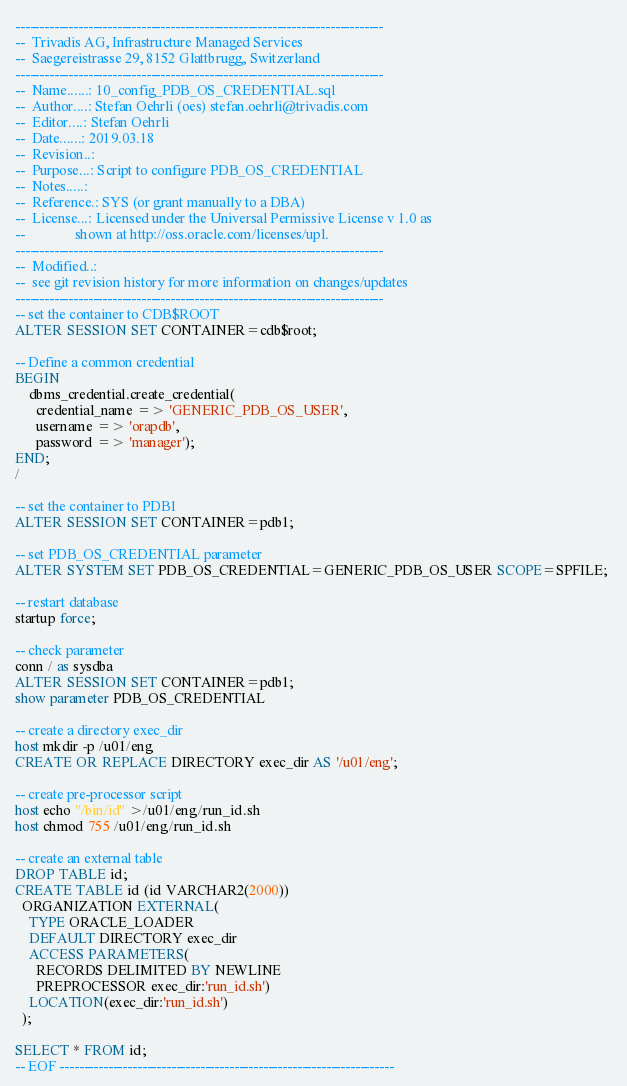<code> <loc_0><loc_0><loc_500><loc_500><_SQL_>----------------------------------------------------------------------------
--  Trivadis AG, Infrastructure Managed Services
--  Saegereistrasse 29, 8152 Glattbrugg, Switzerland
----------------------------------------------------------------------------
--  Name......: 10_config_PDB_OS_CREDENTIAL.sql
--  Author....: Stefan Oehrli (oes) stefan.oehrli@trivadis.com
--  Editor....: Stefan Oehrli
--  Date......: 2019.03.18
--  Revision..:  
--  Purpose...: Script to configure PDB_OS_CREDENTIAL
--  Notes.....:  
--  Reference.: SYS (or grant manually to a DBA)
--  License...: Licensed under the Universal Permissive License v 1.0 as 
--              shown at http://oss.oracle.com/licenses/upl.
----------------------------------------------------------------------------
--  Modified..:
--  see git revision history for more information on changes/updates
----------------------------------------------------------------------------
-- set the container to CDB$ROOT
ALTER SESSION SET CONTAINER=cdb$root;

-- Define a common credential
BEGIN
    dbms_credential.create_credential(
      credential_name => 'GENERIC_PDB_OS_USER',
      username => 'orapdb',
      password => 'manager');
END;
/

-- set the container to PDB1
ALTER SESSION SET CONTAINER=pdb1;

-- set PDB_OS_CREDENTIAL parameter
ALTER SYSTEM SET PDB_OS_CREDENTIAL=GENERIC_PDB_OS_USER SCOPE=SPFILE; 

-- restart database
startup force;

-- check parameter
conn / as sysdba
ALTER SESSION SET CONTAINER=pdb1;
show parameter PDB_OS_CREDENTIAL

-- create a directory exec_dir
host mkdir -p /u01/eng
CREATE OR REPLACE DIRECTORY exec_dir AS '/u01/eng'; 

-- create pre-processor script
host echo "/bin/id" >/u01/eng/run_id.sh
host chmod 755 /u01/eng/run_id.sh

-- create an external table
DROP TABLE id;
CREATE TABLE id (id VARCHAR2(2000)) 
  ORGANIZATION EXTERNAL( 
    TYPE ORACLE_LOADER 
    DEFAULT DIRECTORY exec_dir 
    ACCESS PARAMETERS( 
      RECORDS DELIMITED BY NEWLINE 
      PREPROCESSOR exec_dir:'run_id.sh') 
    LOCATION(exec_dir:'run_id.sh') 
  ); 

SELECT * FROM id;
-- EOF ---------------------------------------------------------------------
</code> 